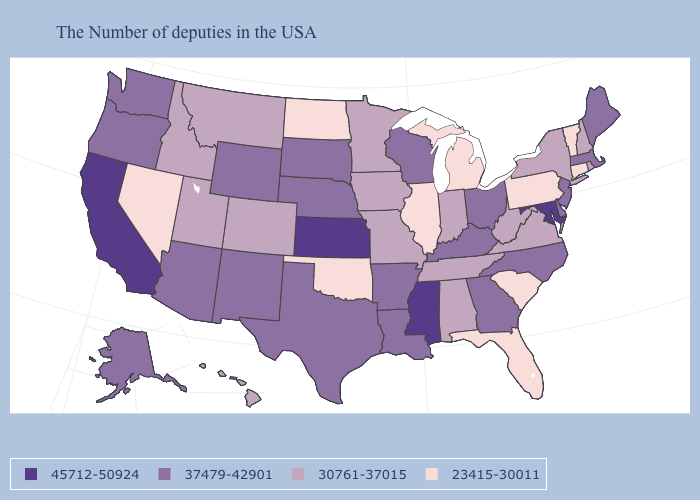What is the highest value in states that border Massachusetts?
Short answer required. 30761-37015. Which states have the lowest value in the MidWest?
Short answer required. Michigan, Illinois, North Dakota. What is the value of Pennsylvania?
Keep it brief. 23415-30011. Name the states that have a value in the range 30761-37015?
Write a very short answer. Rhode Island, New Hampshire, New York, Virginia, West Virginia, Indiana, Alabama, Tennessee, Missouri, Minnesota, Iowa, Colorado, Utah, Montana, Idaho, Hawaii. Among the states that border North Dakota , does South Dakota have the lowest value?
Be succinct. No. Name the states that have a value in the range 45712-50924?
Be succinct. Maryland, Mississippi, Kansas, California. Name the states that have a value in the range 45712-50924?
Quick response, please. Maryland, Mississippi, Kansas, California. Among the states that border Oklahoma , does Missouri have the lowest value?
Answer briefly. Yes. What is the value of Hawaii?
Keep it brief. 30761-37015. Does New Mexico have a higher value than Hawaii?
Give a very brief answer. Yes. Does the first symbol in the legend represent the smallest category?
Give a very brief answer. No. Name the states that have a value in the range 30761-37015?
Keep it brief. Rhode Island, New Hampshire, New York, Virginia, West Virginia, Indiana, Alabama, Tennessee, Missouri, Minnesota, Iowa, Colorado, Utah, Montana, Idaho, Hawaii. Among the states that border Oregon , which have the lowest value?
Keep it brief. Nevada. Name the states that have a value in the range 23415-30011?
Write a very short answer. Vermont, Connecticut, Pennsylvania, South Carolina, Florida, Michigan, Illinois, Oklahoma, North Dakota, Nevada. Is the legend a continuous bar?
Write a very short answer. No. 